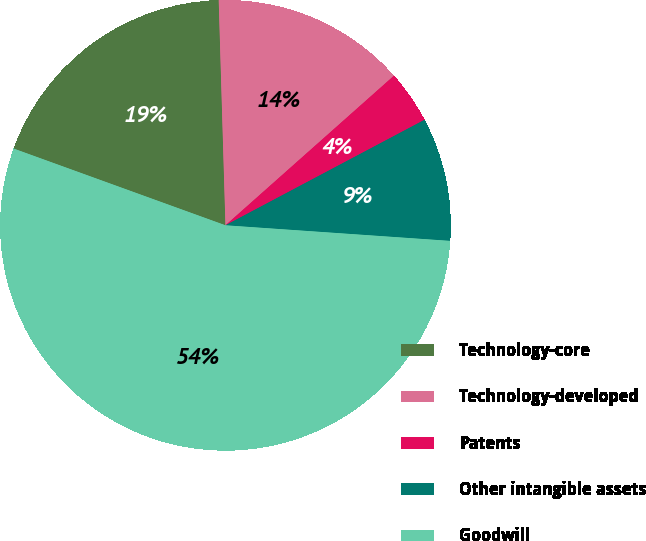Convert chart to OTSL. <chart><loc_0><loc_0><loc_500><loc_500><pie_chart><fcel>Technology-core<fcel>Technology-developed<fcel>Patents<fcel>Other intangible assets<fcel>Goodwill<nl><fcel>18.99%<fcel>13.92%<fcel>3.8%<fcel>8.86%<fcel>54.43%<nl></chart> 